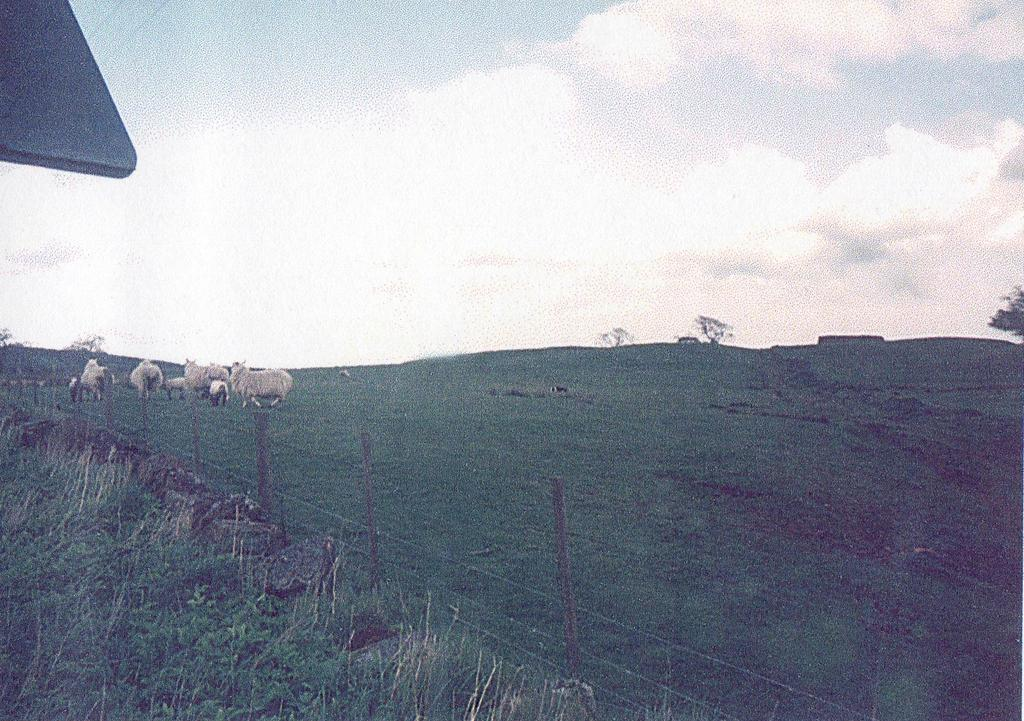What animals are present in the image? There are sheeps in the image. Where are the sheeps located? The sheeps are on the grass. What is on the left side of the sheeps? There are poles with wire fence on the left side of the sheeps. What type of vegetation can be seen in the image? There is grass visible in the image. What is the object on the left side of the sheeps? The object on the left side of the sheeps is not specified in the facts, but it is likely the same wire fence mentioned earlier. What can be seen in the background of the image? The sky is visible behind the sheeps. Can you tell me how fast the grandmother is running in the image? There is no grandmother or running depicted in the image; it features sheeps on grass with a wire fence and the sky visible in the background. 